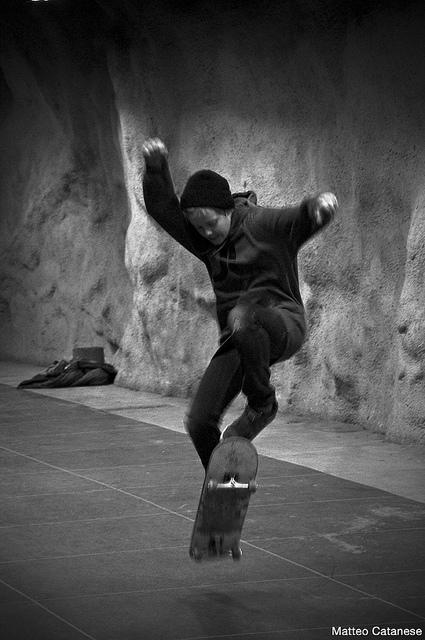What is the boy wearing on his head? Please explain your reasoning. beanie. A skateboarder is wearing a stocking cap. stocking caps are often called beanies. 